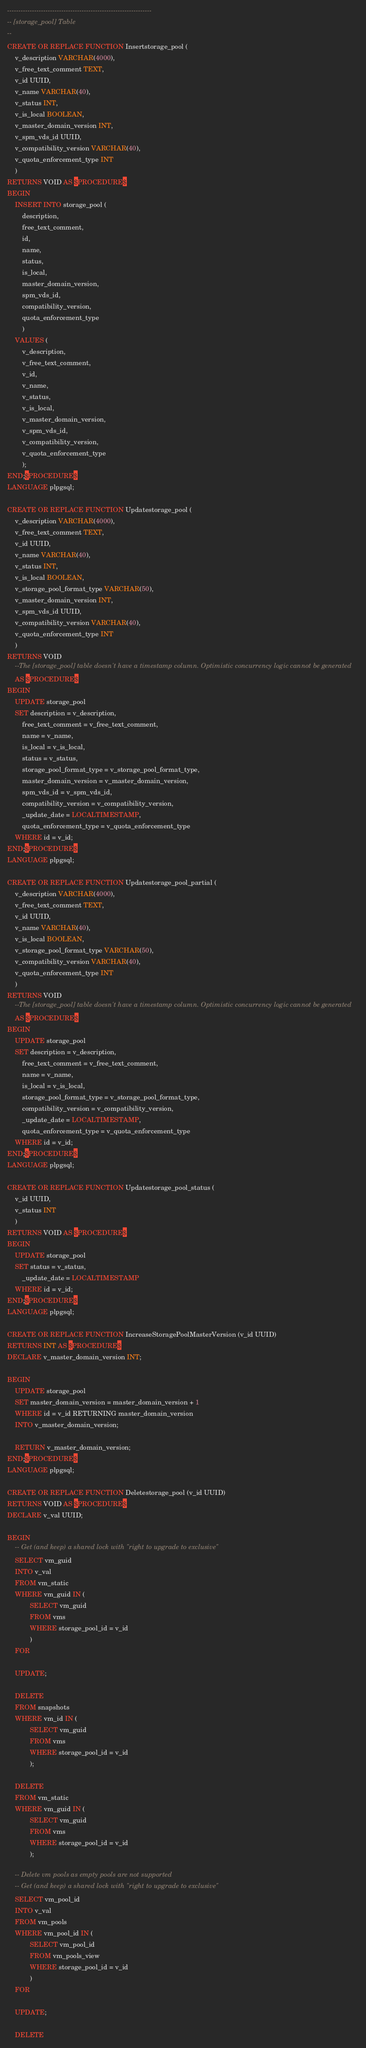<code> <loc_0><loc_0><loc_500><loc_500><_SQL_>

----------------------------------------------------------------
-- [storage_pool] Table
--
CREATE OR REPLACE FUNCTION Insertstorage_pool (
    v_description VARCHAR(4000),
    v_free_text_comment TEXT,
    v_id UUID,
    v_name VARCHAR(40),
    v_status INT,
    v_is_local BOOLEAN,
    v_master_domain_version INT,
    v_spm_vds_id UUID,
    v_compatibility_version VARCHAR(40),
    v_quota_enforcement_type INT
    )
RETURNS VOID AS $PROCEDURE$
BEGIN
    INSERT INTO storage_pool (
        description,
        free_text_comment,
        id,
        name,
        status,
        is_local,
        master_domain_version,
        spm_vds_id,
        compatibility_version,
        quota_enforcement_type
        )
    VALUES (
        v_description,
        v_free_text_comment,
        v_id,
        v_name,
        v_status,
        v_is_local,
        v_master_domain_version,
        v_spm_vds_id,
        v_compatibility_version,
        v_quota_enforcement_type
        );
END;$PROCEDURE$
LANGUAGE plpgsql;

CREATE OR REPLACE FUNCTION Updatestorage_pool (
    v_description VARCHAR(4000),
    v_free_text_comment TEXT,
    v_id UUID,
    v_name VARCHAR(40),
    v_status INT,
    v_is_local BOOLEAN,
    v_storage_pool_format_type VARCHAR(50),
    v_master_domain_version INT,
    v_spm_vds_id UUID,
    v_compatibility_version VARCHAR(40),
    v_quota_enforcement_type INT
    )
RETURNS VOID
    --The [storage_pool] table doesn't have a timestamp column. Optimistic concurrency logic cannot be generated
    AS $PROCEDURE$
BEGIN
    UPDATE storage_pool
    SET description = v_description,
        free_text_comment = v_free_text_comment,
        name = v_name,
        is_local = v_is_local,
        status = v_status,
        storage_pool_format_type = v_storage_pool_format_type,
        master_domain_version = v_master_domain_version,
        spm_vds_id = v_spm_vds_id,
        compatibility_version = v_compatibility_version,
        _update_date = LOCALTIMESTAMP,
        quota_enforcement_type = v_quota_enforcement_type
    WHERE id = v_id;
END;$PROCEDURE$
LANGUAGE plpgsql;

CREATE OR REPLACE FUNCTION Updatestorage_pool_partial (
    v_description VARCHAR(4000),
    v_free_text_comment TEXT,
    v_id UUID,
    v_name VARCHAR(40),
    v_is_local BOOLEAN,
    v_storage_pool_format_type VARCHAR(50),
    v_compatibility_version VARCHAR(40),
    v_quota_enforcement_type INT
    )
RETURNS VOID
    --The [storage_pool] table doesn't have a timestamp column. Optimistic concurrency logic cannot be generated
    AS $PROCEDURE$
BEGIN
    UPDATE storage_pool
    SET description = v_description,
        free_text_comment = v_free_text_comment,
        name = v_name,
        is_local = v_is_local,
        storage_pool_format_type = v_storage_pool_format_type,
        compatibility_version = v_compatibility_version,
        _update_date = LOCALTIMESTAMP,
        quota_enforcement_type = v_quota_enforcement_type
    WHERE id = v_id;
END;$PROCEDURE$
LANGUAGE plpgsql;

CREATE OR REPLACE FUNCTION Updatestorage_pool_status (
    v_id UUID,
    v_status INT
    )
RETURNS VOID AS $PROCEDURE$
BEGIN
    UPDATE storage_pool
    SET status = v_status,
        _update_date = LOCALTIMESTAMP
    WHERE id = v_id;
END;$PROCEDURE$
LANGUAGE plpgsql;

CREATE OR REPLACE FUNCTION IncreaseStoragePoolMasterVersion (v_id UUID)
RETURNS INT AS $PROCEDURE$
DECLARE v_master_domain_version INT;

BEGIN
    UPDATE storage_pool
    SET master_domain_version = master_domain_version + 1
    WHERE id = v_id RETURNING master_domain_version
    INTO v_master_domain_version;

    RETURN v_master_domain_version;
END;$PROCEDURE$
LANGUAGE plpgsql;

CREATE OR REPLACE FUNCTION Deletestorage_pool (v_id UUID)
RETURNS VOID AS $PROCEDURE$
DECLARE v_val UUID;

BEGIN
    -- Get (and keep) a shared lock with "right to upgrade to exclusive"
    SELECT vm_guid
    INTO v_val
    FROM vm_static
    WHERE vm_guid IN (
            SELECT vm_guid
            FROM vms
            WHERE storage_pool_id = v_id
            )
    FOR

    UPDATE;

    DELETE
    FROM snapshots
    WHERE vm_id IN (
            SELECT vm_guid
            FROM vms
            WHERE storage_pool_id = v_id
            );

    DELETE
    FROM vm_static
    WHERE vm_guid IN (
            SELECT vm_guid
            FROM vms
            WHERE storage_pool_id = v_id
            );

    -- Delete vm pools as empty pools are not supported
    -- Get (and keep) a shared lock with "right to upgrade to exclusive"
    SELECT vm_pool_id
    INTO v_val
    FROM vm_pools
    WHERE vm_pool_id IN (
            SELECT vm_pool_id
            FROM vm_pools_view
            WHERE storage_pool_id = v_id
            )
    FOR

    UPDATE;

    DELETE</code> 